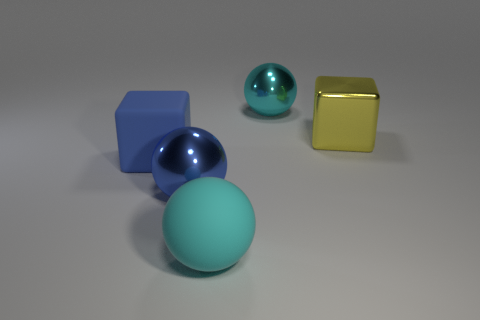Add 4 tiny blue shiny cubes. How many objects exist? 9 Subtract all cubes. How many objects are left? 3 Subtract all blue matte cubes. Subtract all cyan cylinders. How many objects are left? 4 Add 1 big blue matte cubes. How many big blue matte cubes are left? 2 Add 2 shiny things. How many shiny things exist? 5 Subtract 1 yellow blocks. How many objects are left? 4 